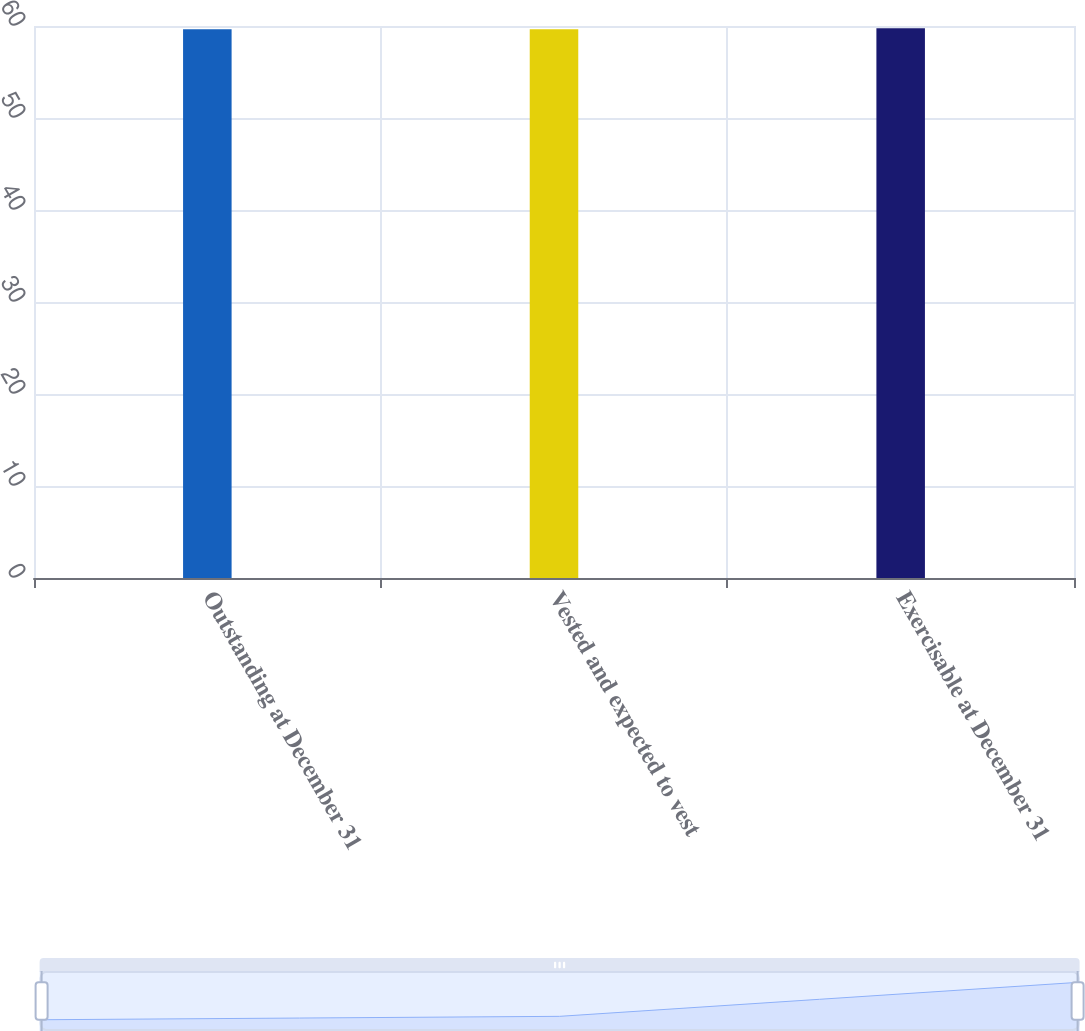Convert chart to OTSL. <chart><loc_0><loc_0><loc_500><loc_500><bar_chart><fcel>Outstanding at December 31<fcel>Vested and expected to vest<fcel>Exercisable at December 31<nl><fcel>59.65<fcel>59.66<fcel>59.76<nl></chart> 